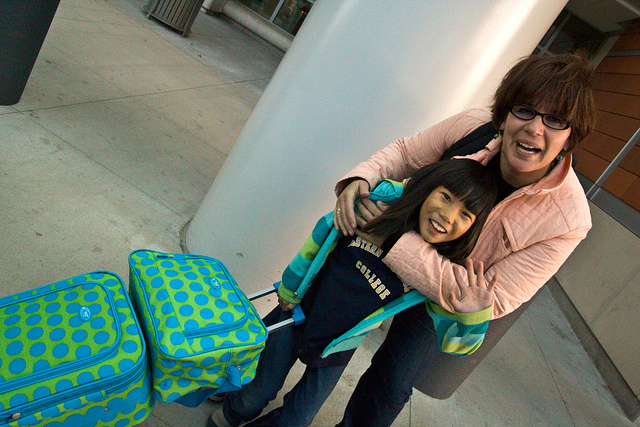What kind of trip do you think they are preparing for based on their attire and luggage? Considering their relaxed and casual attire, along with the playful design of the luggage, they are possibly preparing for a leisurely trip such as a family vacation. They seem dressed for comfort and ease of movement, which is suitable for travel where relaxation and enjoyment are the main goals. 